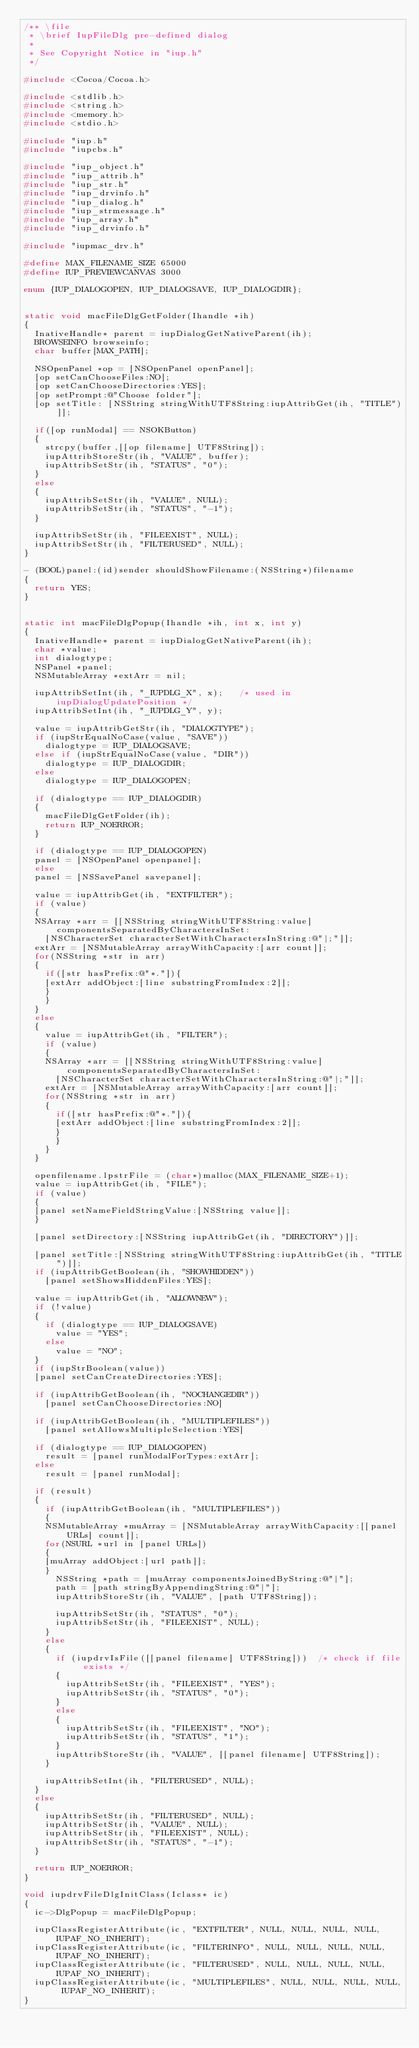Convert code to text. <code><loc_0><loc_0><loc_500><loc_500><_C_>/** \file
 * \brief IupFileDlg pre-defined dialog
 *
 * See Copyright Notice in "iup.h"
 */

#include <Cocoa/Cocoa.h>

#include <stdlib.h>
#include <string.h>
#include <memory.h>
#include <stdio.h>

#include "iup.h"
#include "iupcbs.h"

#include "iup_object.h"
#include "iup_attrib.h"
#include "iup_str.h"
#include "iup_drvinfo.h"
#include "iup_dialog.h"
#include "iup_strmessage.h"
#include "iup_array.h"
#include "iup_drvinfo.h"

#include "iupmac_drv.h"

#define MAX_FILENAME_SIZE 65000
#define IUP_PREVIEWCANVAS 3000

enum {IUP_DIALOGOPEN, IUP_DIALOGSAVE, IUP_DIALOGDIR};
                           

static void macFileDlgGetFolder(Ihandle *ih)
{
  InativeHandle* parent = iupDialogGetNativeParent(ih);
  BROWSEINFO browseinfo;
  char buffer[MAX_PATH];  

  NSOpenPanel *op = [NSOpenPanel openPanel];
  [op setCanChooseFiles:NO];
  [op setCanChooseDirectories:YES];
  [op setPrompt:@"Choose folder"];
  [op setTitle: [NSString stringWithUTF8String:iupAttribGet(ih, "TITLE")]];

  if([op runModal] == NSOKButton) 
  {           
    strcpy(buffer,[[op filename] UTF8String]);                       
    iupAttribStoreStr(ih, "VALUE", buffer);
    iupAttribSetStr(ih, "STATUS", "0");	
  }  
  else 
  {
    iupAttribSetStr(ih, "VALUE", NULL);
    iupAttribSetStr(ih, "STATUS", "-1");	
  }  

  iupAttribSetStr(ih, "FILEEXIST", NULL);
  iupAttribSetStr(ih, "FILTERUSED", NULL);
}
 
- (BOOL)panel:(id)sender shouldShowFilename:(NSString*)filename
{    
	return YES;
}


static int macFileDlgPopup(Ihandle *ih, int x, int y)
{
  InativeHandle* parent = iupDialogGetNativeParent(ih);    
  char *value;    
  int dialogtype;       
  NSPanel *panel;    
  NSMutableArray *extArr = nil;

  iupAttribSetInt(ih, "_IUPDLG_X", x);   /* used in iupDialogUpdatePosition */
  iupAttribSetInt(ih, "_IUPDLG_Y", y);

  value = iupAttribGetStr(ih, "DIALOGTYPE");
  if (iupStrEqualNoCase(value, "SAVE"))
    dialogtype = IUP_DIALOGSAVE;
  else if (iupStrEqualNoCase(value, "DIR"))
    dialogtype = IUP_DIALOGDIR;
  else
    dialogtype = IUP_DIALOGOPEN;

  if (dialogtype == IUP_DIALOGDIR)
  {
    macFileDlgGetFolder(ih);
    return IUP_NOERROR;
  }

  if (dialogtype == IUP_DIALOGOPEN)
	panel = [NSOpenPanel openpanel];
  else
	panel = [NSSavePanel savepanel];

  value = iupAttribGet(ih, "EXTFILTER");
  if (value)
  {
	NSArray *arr = [[NSString stringWithUTF8String:value] componentsSeparatedByCharactersInSet:
		[NSCharacterSet characterSetWithCharactersInString:@"|;"]];  
	extArr = [NSMutableArray arrayWithCapacity:[arr count]];
	for(NSString *str in arr)
	{
	  if([str hasPrefix:@"*."]){
		[extArr addObject:[line substringFromIndex:2]];
	  }
    }
  }
  else 
  {
    value = iupAttribGet(ih, "FILTER");
    if (value)
    {
		NSArray *arr = [[NSString stringWithUTF8String:value] componentsSeparatedByCharactersInSet:
			[NSCharacterSet characterSetWithCharactersInString:@"|;"]];  
		extArr = [NSMutableArray arrayWithCapacity:[arr count]];
		for(NSString *str in arr)
		{
		  if([str hasPrefix:@"*."]){
			[extArr addObject:[line substringFromIndex:2]];
		  }
	    }
    }
  }

  openfilename.lpstrFile = (char*)malloc(MAX_FILENAME_SIZE+1);
  value = iupAttribGet(ih, "FILE");
  if (value)
  {
	[panel setNameFieldStringValue:[NSString value]];
  }

  [panel setDirectory:[NSString iupAttribGet(ih, "DIRECTORY")]];  

  [panel setTitle:[NSString stringWithUTF8String:iupAttribGet(ih, "TITLE")]];
  if (iupAttribGetBoolean(ih, "SHOWHIDDEN"))
    [panel setShowsHiddenFiles:YES];

  value = iupAttribGet(ih, "ALLOWNEW");
  if (!value)
  {
    if (dialogtype == IUP_DIALOGSAVE)
      value = "YES";
    else
      value = "NO";
  }
  if (iupStrBoolean(value))
	[panel setCanCreateDirectories:YES];

  if (iupAttribGetBoolean(ih, "NOCHANGEDIR"))
    [panel setCanChooseDirectories:NO]

  if (iupAttribGetBoolean(ih, "MULTIPLEFILES"))
    [panel setAllowsMultipleSelection:YES]

  if (dialogtype == IUP_DIALOGOPEN)
    result = [panel runModalForTypes:extArr];
  else
    result = [panel runModal];

  if (result)
  {
    if (iupAttribGetBoolean(ih, "MULTIPLEFILES"))
    {            
	  NSMutableArray *muArray = [NSMutableArray arrayWithCapacity:[[panel URLs] count]];
	  for(NSURL *url in [panel URLs])
	  {
		[muArray addObject:[url path]];  
	  }              
      NSString *path = [muArray componentsJoinedByString:@"|"];  
  	  path = [path stringByAppendingString:@"|"];
      iupAttribStoreStr(ih, "VALUE", [path UTF8String]);      

      iupAttribSetStr(ih, "STATUS", "0");
      iupAttribSetStr(ih, "FILEEXIST", NULL);
    }
    else
    {
      if (iupdrvIsFile([[panel filename] UTF8String]))  /* check if file exists */
      {
        iupAttribSetStr(ih, "FILEEXIST", "YES");
        iupAttribSetStr(ih, "STATUS", "0");
      }
      else
      {
        iupAttribSetStr(ih, "FILEEXIST", "NO");
        iupAttribSetStr(ih, "STATUS", "1");
      }
      iupAttribStoreStr(ih, "VALUE", [[panel filename] UTF8String]);
    }

    iupAttribSetInt(ih, "FILTERUSED", NULL);
  }
  else
  {
    iupAttribSetStr(ih, "FILTERUSED", NULL);
    iupAttribSetStr(ih, "VALUE", NULL);
    iupAttribSetStr(ih, "FILEEXIST", NULL);
    iupAttribSetStr(ih, "STATUS", "-1");
  }

  return IUP_NOERROR;
}

void iupdrvFileDlgInitClass(Iclass* ic)
{
  ic->DlgPopup = macFileDlgPopup;

  iupClassRegisterAttribute(ic, "EXTFILTER", NULL, NULL, NULL, NULL, IUPAF_NO_INHERIT);
  iupClassRegisterAttribute(ic, "FILTERINFO", NULL, NULL, NULL, NULL, IUPAF_NO_INHERIT);
  iupClassRegisterAttribute(ic, "FILTERUSED", NULL, NULL, NULL, NULL, IUPAF_NO_INHERIT);
  iupClassRegisterAttribute(ic, "MULTIPLEFILES", NULL, NULL, NULL, NULL, IUPAF_NO_INHERIT);
}
</code> 